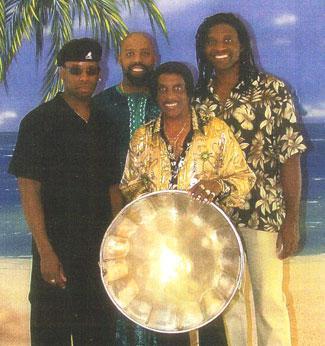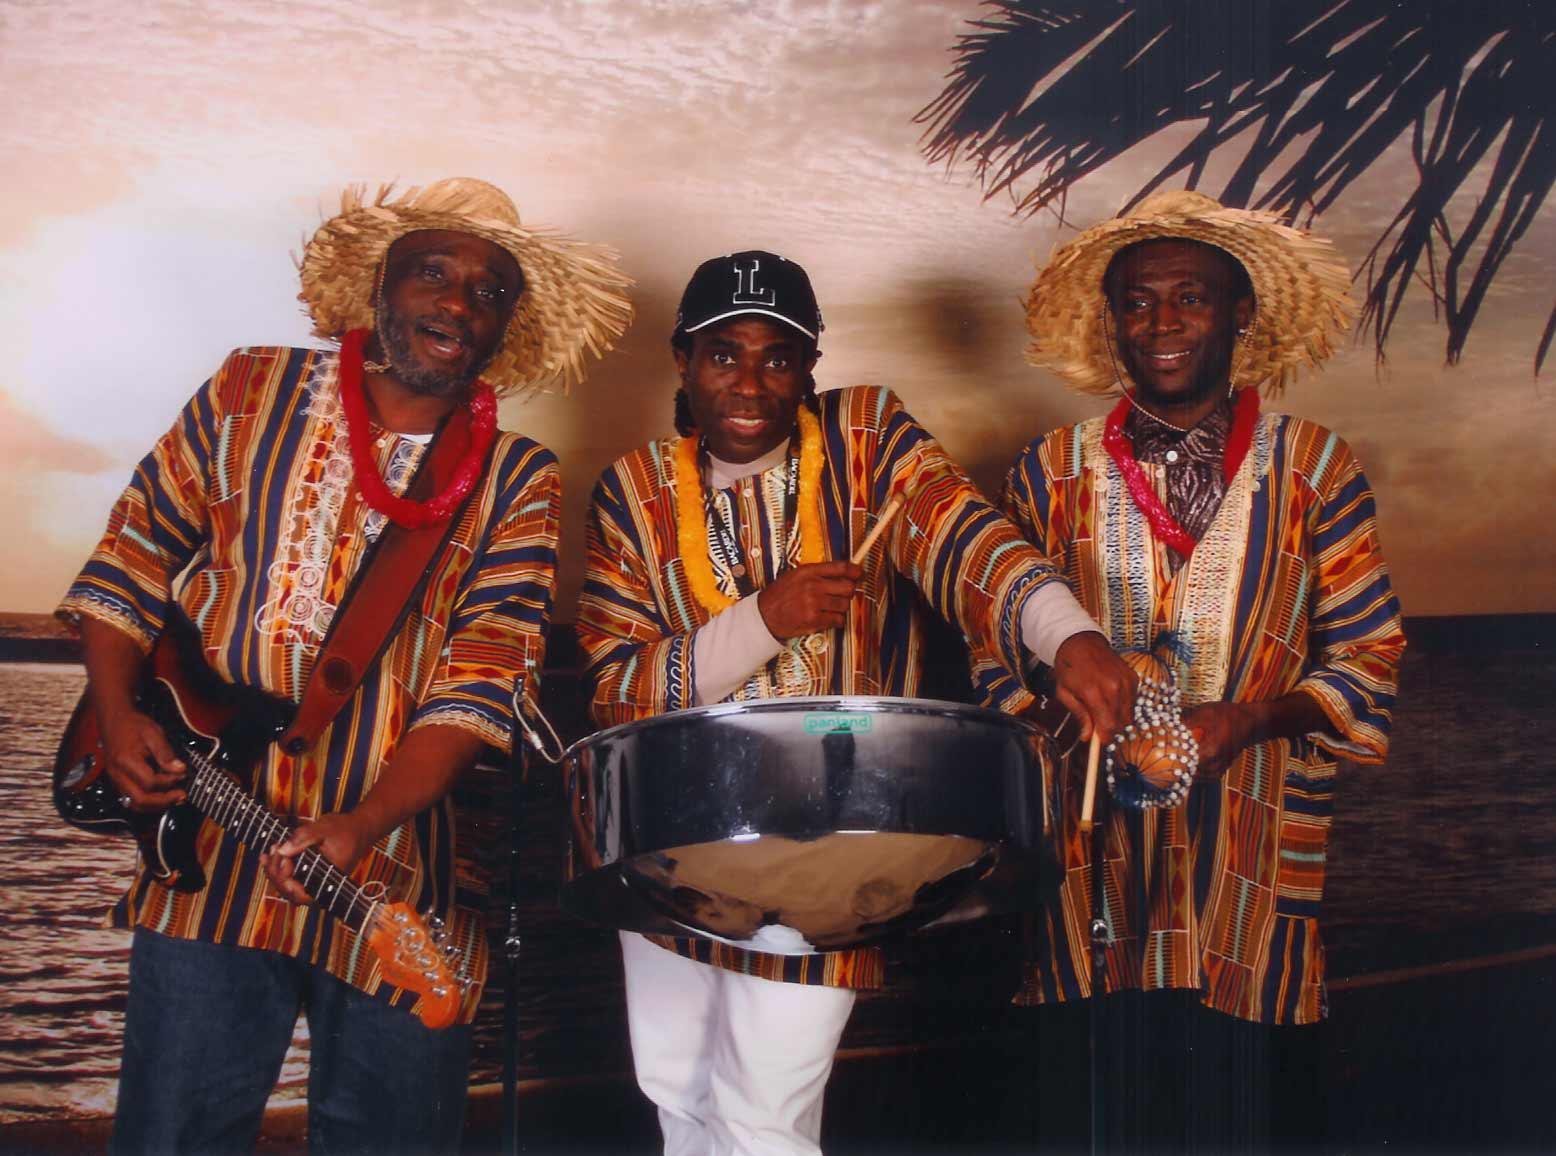The first image is the image on the left, the second image is the image on the right. Evaluate the accuracy of this statement regarding the images: "The right image shows a line of standing drummers in shiny fedora hats, with silver drums on stands in front of them.". Is it true? Answer yes or no. No. The first image is the image on the left, the second image is the image on the right. Considering the images on both sides, is "In one image, every musician is wearing a hat." valid? Answer yes or no. Yes. 